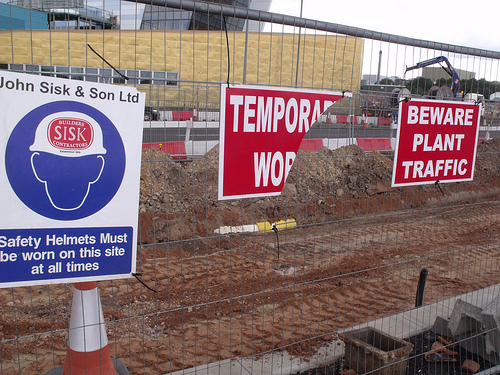<image>
Can you confirm if the sign is on the building? No. The sign is not positioned on the building. They may be near each other, but the sign is not supported by or resting on top of the building. 